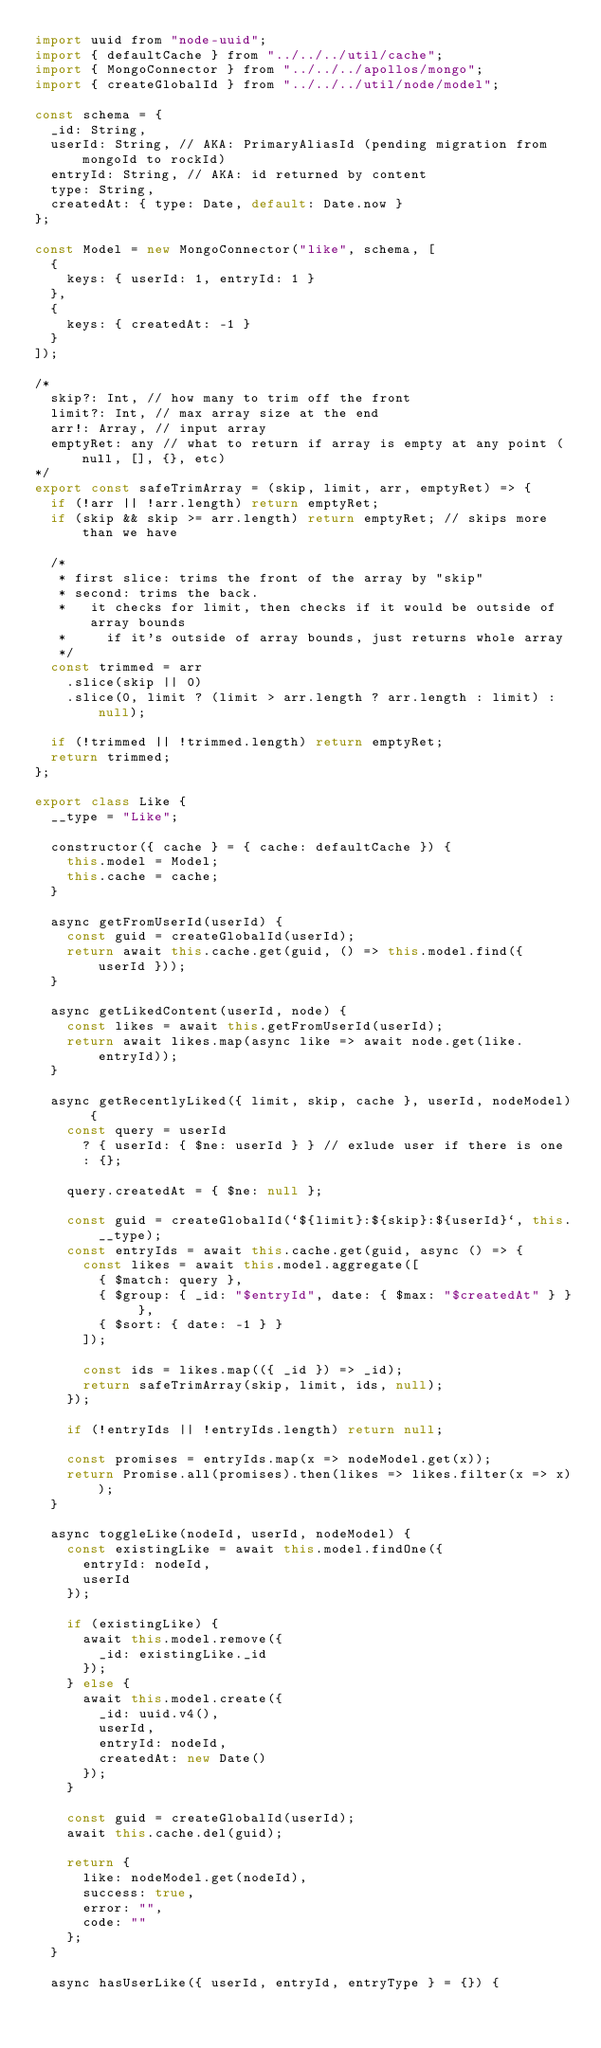Convert code to text. <code><loc_0><loc_0><loc_500><loc_500><_JavaScript_>import uuid from "node-uuid";
import { defaultCache } from "../../../util/cache";
import { MongoConnector } from "../../../apollos/mongo";
import { createGlobalId } from "../../../util/node/model";

const schema = {
  _id: String,
  userId: String, // AKA: PrimaryAliasId (pending migration from mongoId to rockId)
  entryId: String, // AKA: id returned by content
  type: String,
  createdAt: { type: Date, default: Date.now }
};

const Model = new MongoConnector("like", schema, [
  {
    keys: { userId: 1, entryId: 1 }
  },
  {
    keys: { createdAt: -1 }
  }
]);

/*
  skip?: Int, // how many to trim off the front
  limit?: Int, // max array size at the end
  arr!: Array, // input array
  emptyRet: any // what to return if array is empty at any point (null, [], {}, etc)
*/
export const safeTrimArray = (skip, limit, arr, emptyRet) => {
  if (!arr || !arr.length) return emptyRet;
  if (skip && skip >= arr.length) return emptyRet; // skips more than we have

  /*
   * first slice: trims the front of the array by "skip"
   * second: trims the back.
   *   it checks for limit, then checks if it would be outside of array bounds
   *     if it's outside of array bounds, just returns whole array
   */
  const trimmed = arr
    .slice(skip || 0)
    .slice(0, limit ? (limit > arr.length ? arr.length : limit) : null);

  if (!trimmed || !trimmed.length) return emptyRet;
  return trimmed;
};

export class Like {
  __type = "Like";

  constructor({ cache } = { cache: defaultCache }) {
    this.model = Model;
    this.cache = cache;
  }

  async getFromUserId(userId) {
    const guid = createGlobalId(userId);
    return await this.cache.get(guid, () => this.model.find({ userId }));
  }

  async getLikedContent(userId, node) {
    const likes = await this.getFromUserId(userId);
    return await likes.map(async like => await node.get(like.entryId));
  }

  async getRecentlyLiked({ limit, skip, cache }, userId, nodeModel) {
    const query = userId
      ? { userId: { $ne: userId } } // exlude user if there is one
      : {};

    query.createdAt = { $ne: null };

    const guid = createGlobalId(`${limit}:${skip}:${userId}`, this.__type);
    const entryIds = await this.cache.get(guid, async () => {
      const likes = await this.model.aggregate([
        { $match: query },
        { $group: { _id: "$entryId", date: { $max: "$createdAt" } } },
        { $sort: { date: -1 } }
      ]);

      const ids = likes.map(({ _id }) => _id);
      return safeTrimArray(skip, limit, ids, null);
    });

    if (!entryIds || !entryIds.length) return null;

    const promises = entryIds.map(x => nodeModel.get(x));
    return Promise.all(promises).then(likes => likes.filter(x => x));
  }

  async toggleLike(nodeId, userId, nodeModel) {
    const existingLike = await this.model.findOne({
      entryId: nodeId,
      userId
    });

    if (existingLike) {
      await this.model.remove({
        _id: existingLike._id
      });
    } else {
      await this.model.create({
        _id: uuid.v4(),
        userId,
        entryId: nodeId,
        createdAt: new Date()
      });
    }

    const guid = createGlobalId(userId);
    await this.cache.del(guid);

    return {
      like: nodeModel.get(nodeId),
      success: true,
      error: "",
      code: ""
    };
  }

  async hasUserLike({ userId, entryId, entryType } = {}) {</code> 